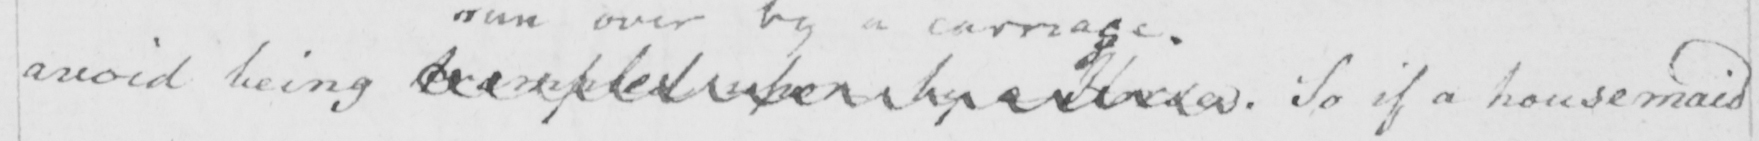Transcribe the text shown in this historical manuscript line. avoid being trampled upon by a horse  . So if a housemaid 